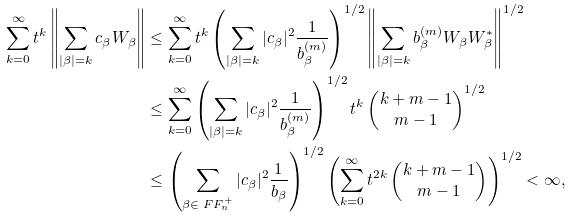<formula> <loc_0><loc_0><loc_500><loc_500>\sum _ { k = 0 } ^ { \infty } t ^ { k } \left \| \sum _ { | \beta | = k } c _ { \beta } W _ { \beta } \right \| & \leq \sum _ { k = 0 } ^ { \infty } t ^ { k } \left ( \sum _ { | \beta | = k } | c _ { \beta } | ^ { 2 } \frac { 1 } { b ^ { ( m ) } _ { \beta } } \right ) ^ { 1 / 2 } \left \| \sum _ { | \beta | = k } b ^ { ( m ) } _ { \beta } W _ { \beta } W _ { \beta } ^ { * } \right \| ^ { 1 / 2 } \\ & \leq \sum _ { k = 0 } ^ { \infty } \left ( \sum _ { | \beta | = k } | c _ { \beta } | ^ { 2 } \frac { 1 } { b ^ { ( m ) } _ { \beta } } \right ) ^ { 1 / 2 } t ^ { k } \left ( \begin{matrix} k + m - 1 \\ m - 1 \end{matrix} \right ) ^ { 1 / 2 } \\ & \leq \left ( \sum _ { \beta \in \ F F _ { n } ^ { + } } | c _ { \beta } | ^ { 2 } \frac { 1 } { b _ { \beta } } \right ) ^ { 1 / 2 } \left ( \sum _ { k = 0 } ^ { \infty } t ^ { 2 k } \left ( \begin{matrix} k + m - 1 \\ m - 1 \end{matrix} \right ) \right ) ^ { 1 / 2 } < \infty ,</formula> 